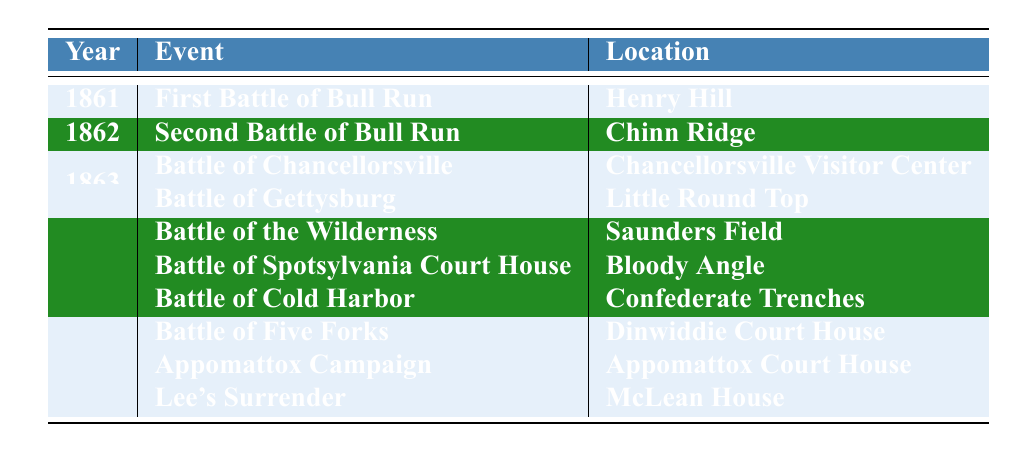What year did the First Battle of Bull Run occur? The table shows that the First Battle of Bull Run took place in the year 1861, as indicated in the 'Year' column next to the event title.
Answer: 1861 Where was the Battle of Gettysburg fought? The table lists the location of the Battle of Gettysburg under the 'Location' column, which states that it was fought at Little Round Top.
Answer: Little Round Top How many events occurred in the year 1864? From the table, we see there are three events listed for the year 1864: Battle of the Wilderness, Battle of Spotsylvania Court House, and Battle of Cold Harbor. Counting these gives us a total of three events.
Answer: 3 True or False: The Appomattox Campaign took place in 1864. The table shows that the Appomattox Campaign is listed in the year 1865, thus making the statement false.
Answer: False Which event occurred at Saunders Field? By looking at the table, we can see that the Battle of the Wilderness occurred at Saunders Field, as indicated in the corresponding row.
Answer: Battle of the Wilderness What is the difference in years between the Battle of Cold Harbor and Lee's Surrender? The Battle of Cold Harbor took place in 1864 and Lee's Surrender in 1865. The difference between these two years is 1865 - 1864 = 1 year.
Answer: 1 year How many battles occurred at Henry Hill? The table lists only one event that occurred at Henry Hill, which is the First Battle of Bull Run in 1861.
Answer: 1 In which year did both the Battle of Five Forks and Lee's Surrender happen? By checking the table, it is evident that both events occurred in the year 1865, as they are listed under that year.
Answer: 1865 Which event had the location of Bloody Angle? The table shows that the event associated with the location of Bloody Angle is the Battle of Spotsylvania Court House.
Answer: Battle of Spotsylvania Court House What is the total number of battles specified in the table? The table lists a total of ten events, which are all battles or campaigns that took place, summing up to ten in total.
Answer: 10 